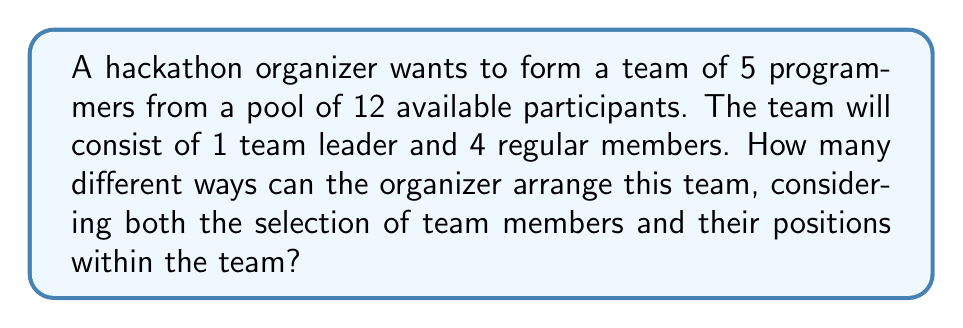Teach me how to tackle this problem. Let's approach this problem step-by-step:

1) First, we need to choose the team leader. There are 12 programmers to choose from, so there are 12 ways to do this.

2) After selecting the team leader, we have 11 programmers left to fill the remaining 4 positions.

3) For the first regular member position, we have 11 choices.

4) For the second regular member position, we have 10 choices.

5) For the third regular member position, we have 9 choices.

6) For the fourth regular member position, we have 8 choices.

7) This scenario represents a permutation problem. We are arranging 5 people (1 leader + 4 members) out of 12, where the order matters.

8) The total number of ways to arrange this team is the product of all these choices:

   $$ 12 \times 11 \times 10 \times 9 \times 8 $$

9) This can be written in factorial notation as:

   $$ \frac{12!}{7!} $$

10) Calculating this:
    
    $$ \frac{12!}{7!} = 12 \times 11 \times 10 \times 9 \times 8 = 95,040 $$

Therefore, there are 95,040 different ways to arrange the team.
Answer: 95,040 